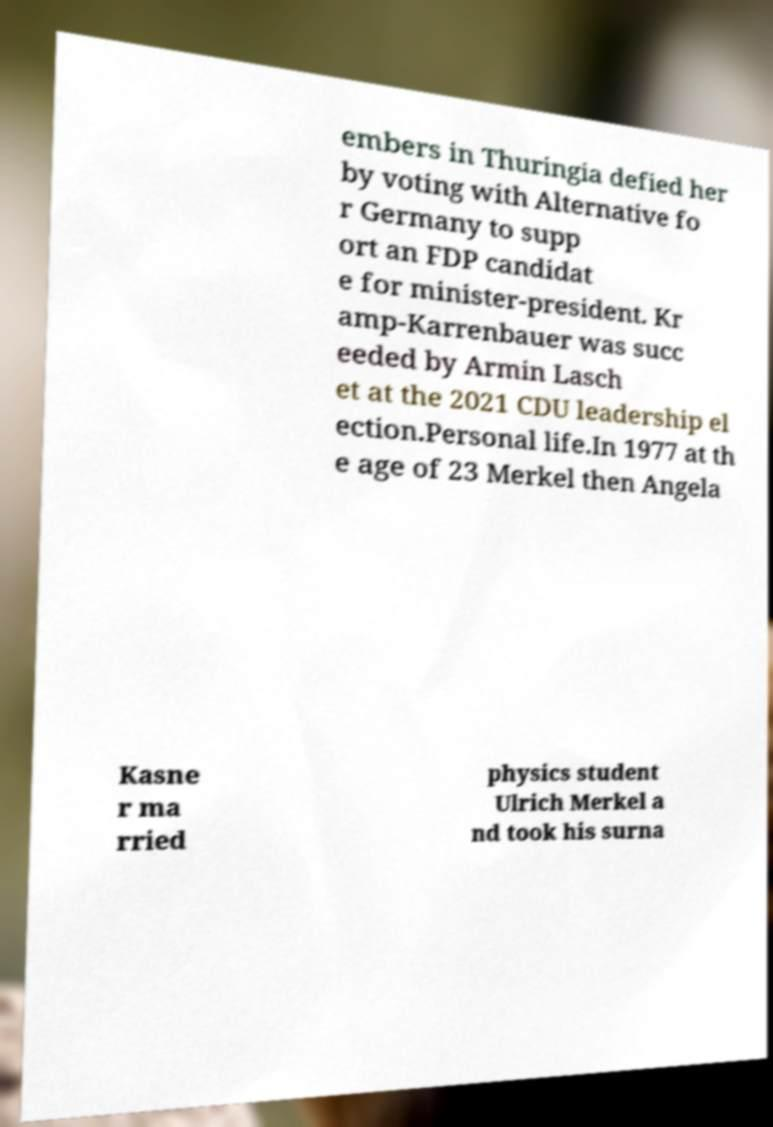Could you extract and type out the text from this image? embers in Thuringia defied her by voting with Alternative fo r Germany to supp ort an FDP candidat e for minister-president. Kr amp-Karrenbauer was succ eeded by Armin Lasch et at the 2021 CDU leadership el ection.Personal life.In 1977 at th e age of 23 Merkel then Angela Kasne r ma rried physics student Ulrich Merkel a nd took his surna 